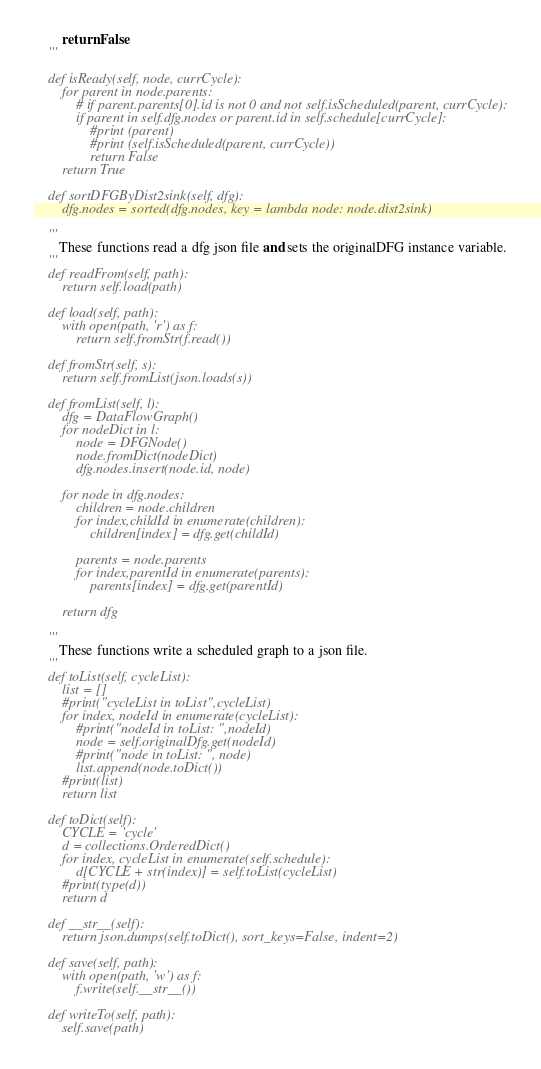<code> <loc_0><loc_0><loc_500><loc_500><_Python_>        return False
    '''

    def isReady(self, node, currCycle):
        for parent in node.parents:
            # if parent.parents[0].id is not 0 and not self.isScheduled(parent, currCycle):
            if parent in self.dfg.nodes or parent.id in self.schedule[currCycle]:
                #print (parent)
                #print (self.isScheduled(parent, currCycle))
                return False
        return True

    def sortDFGByDist2sink(self, dfg):
        dfg.nodes = sorted(dfg.nodes, key = lambda node: node.dist2sink)

    '''
       These functions read a dfg json file and sets the originalDFG instance variable.
    '''
    def readFrom(self, path):
        return self.load(path)

    def load(self, path):
        with open(path, 'r') as f:
            return self.fromStr(f.read())

    def fromStr(self, s):
        return self.fromList(json.loads(s))
    
    def fromList(self, l):
        dfg = DataFlowGraph()
        for nodeDict in l:
            node = DFGNode()
            node.fromDict(nodeDict)
            dfg.nodes.insert(node.id, node)

        for node in dfg.nodes:
            children = node.children
            for index,childId in enumerate(children):
                children[index] = dfg.get(childId)

            parents = node.parents
            for index,parentId in enumerate(parents):
                parents[index] = dfg.get(parentId)
            
        return dfg

    '''
       These functions write a scheduled graph to a json file.
    '''
    def toList(self, cycleList):
        list = []
        #print("cycleList in toList",cycleList)
        for index, nodeId in enumerate(cycleList):
            #print("nodeId in toList: ",nodeId)
            node = self.originalDfg.get(nodeId)
            #print("node in toList: ", node)
            list.append(node.toDict())
        #print(list)
        return list
        
    def toDict(self):
        CYCLE = 'cycle'
        d = collections.OrderedDict()
        for index, cycleList in enumerate(self.schedule):
            d[CYCLE + str(index)] = self.toList(cycleList)
        #print(type(d))
        return d

    def __str__(self):
        return json.dumps(self.toDict(), sort_keys=False, indent=2)

    def save(self, path):
        with open(path, 'w') as f:
            f.write(self.__str__())

    def writeTo(self, path):
        self.save(path)
</code> 